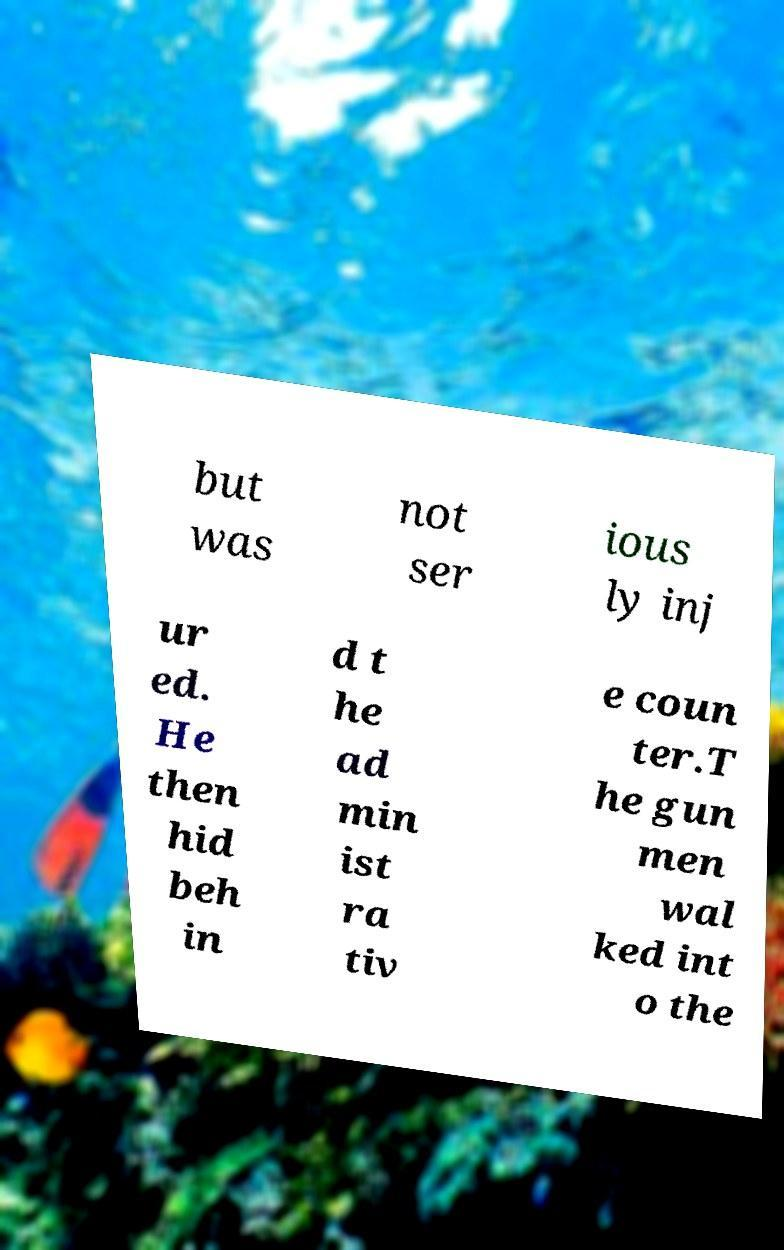There's text embedded in this image that I need extracted. Can you transcribe it verbatim? but was not ser ious ly inj ur ed. He then hid beh in d t he ad min ist ra tiv e coun ter.T he gun men wal ked int o the 